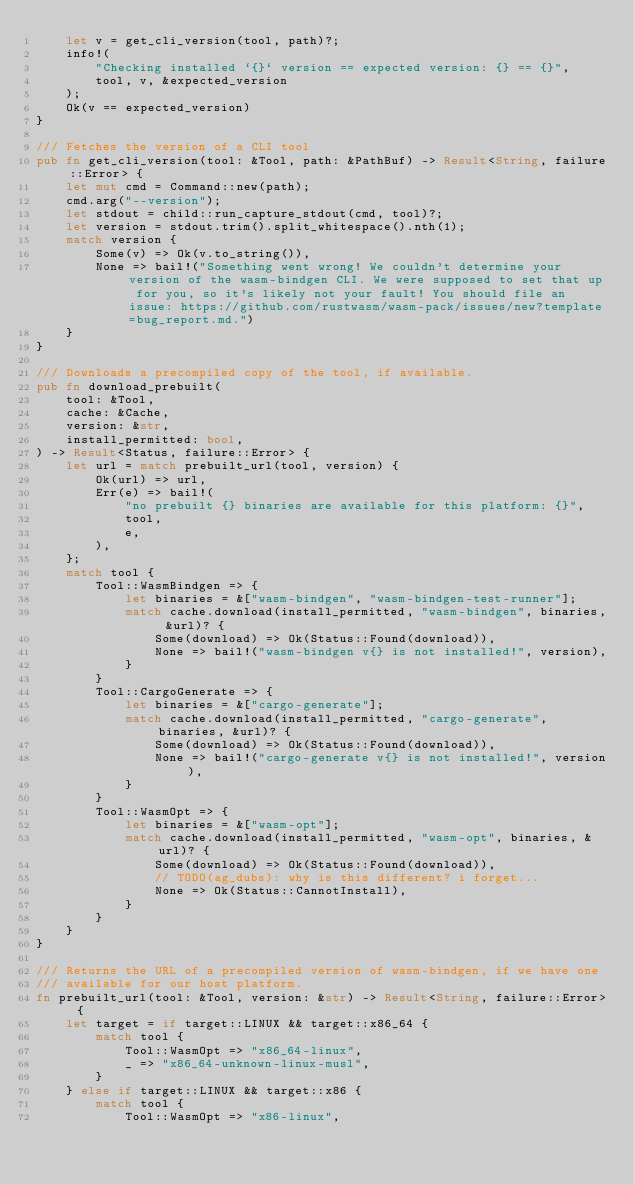Convert code to text. <code><loc_0><loc_0><loc_500><loc_500><_Rust_>    let v = get_cli_version(tool, path)?;
    info!(
        "Checking installed `{}` version == expected version: {} == {}",
        tool, v, &expected_version
    );
    Ok(v == expected_version)
}

/// Fetches the version of a CLI tool
pub fn get_cli_version(tool: &Tool, path: &PathBuf) -> Result<String, failure::Error> {
    let mut cmd = Command::new(path);
    cmd.arg("--version");
    let stdout = child::run_capture_stdout(cmd, tool)?;
    let version = stdout.trim().split_whitespace().nth(1);
    match version {
        Some(v) => Ok(v.to_string()),
        None => bail!("Something went wrong! We couldn't determine your version of the wasm-bindgen CLI. We were supposed to set that up for you, so it's likely not your fault! You should file an issue: https://github.com/rustwasm/wasm-pack/issues/new?template=bug_report.md.")
    }
}

/// Downloads a precompiled copy of the tool, if available.
pub fn download_prebuilt(
    tool: &Tool,
    cache: &Cache,
    version: &str,
    install_permitted: bool,
) -> Result<Status, failure::Error> {
    let url = match prebuilt_url(tool, version) {
        Ok(url) => url,
        Err(e) => bail!(
            "no prebuilt {} binaries are available for this platform: {}",
            tool,
            e,
        ),
    };
    match tool {
        Tool::WasmBindgen => {
            let binaries = &["wasm-bindgen", "wasm-bindgen-test-runner"];
            match cache.download(install_permitted, "wasm-bindgen", binaries, &url)? {
                Some(download) => Ok(Status::Found(download)),
                None => bail!("wasm-bindgen v{} is not installed!", version),
            }
        }
        Tool::CargoGenerate => {
            let binaries = &["cargo-generate"];
            match cache.download(install_permitted, "cargo-generate", binaries, &url)? {
                Some(download) => Ok(Status::Found(download)),
                None => bail!("cargo-generate v{} is not installed!", version),
            }
        }
        Tool::WasmOpt => {
            let binaries = &["wasm-opt"];
            match cache.download(install_permitted, "wasm-opt", binaries, &url)? {
                Some(download) => Ok(Status::Found(download)),
                // TODO(ag_dubs): why is this different? i forget...
                None => Ok(Status::CannotInstall),
            }
        }
    }
}

/// Returns the URL of a precompiled version of wasm-bindgen, if we have one
/// available for our host platform.
fn prebuilt_url(tool: &Tool, version: &str) -> Result<String, failure::Error> {
    let target = if target::LINUX && target::x86_64 {
        match tool {
            Tool::WasmOpt => "x86_64-linux",
            _ => "x86_64-unknown-linux-musl",
        }
    } else if target::LINUX && target::x86 {
        match tool {
            Tool::WasmOpt => "x86-linux",</code> 